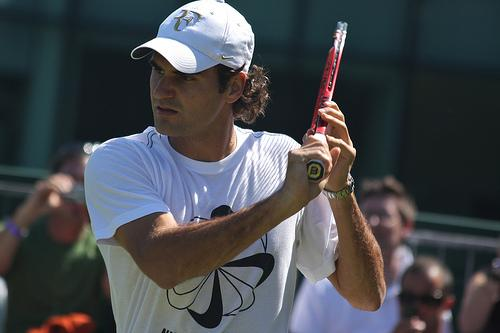What do people wear on their heads in the image? Several people wear hats in this image, including a white hat, a white cap, and a cap with a curled bill. Can you describe the details of the tennis player's outfit? The tennis player is wearing a short-sleeve white t-shirt with a black round design on the chest, a white hat with a letter f and brown curves on it, and a silver wristwatch on his left wrist. Please mention the colors of the tennis racquet and explain its position concerning the player. The tennis racquet is red, white, and blue and is held over the player's shoulder with both hands. What type of hairstyle does the tennis player have? The tennis player has dark brown curly hair, which sticks out from under the back of his cap. Count the number of visible accessories the tennis player is wearing. The tennis player is wearing three visible accessories: a white hat with a design, a silver watch on his left wrist, and a pair of dark sunglasses. What are the people in the background doing? Spectators in the background are watching the tennis player, while a woman takes a photo with her camera and another man records the race on his smartphone. What are the different objects related to a starter gun in the image, and describe their positions. There's a red shaft of starter gun near the top right side of the image and a very bottom of the starter gun and part of a handle towards the middle right of the image. In the scene, describe any interaction between the objects and the tennis player. The tennis player interacts with the racket by holding it with both hands over his shoulder, while his bent elbow crosses his chest and his cap casts a shadow on itself. Assess the overall sentiment or feeling conveyed by the image.  The image conveys a sense of excitement and focus, as the tennis player concentrates on the game, and the spectators watch intently or capture the moment with their devices. Look for the little boy on the far left of the image, wearing a green shirt and holding an ice cream cone. What flavor do you think it is? There is no mention of a little boy or any children in the image information. By posing a question and prompting the viewer to guess the ice cream flavor, it distracts from the actual objects and creates intrigue around a nonexistent figure. What is the main color of the man's hat? White Which of the following colors is an element of the tennis racquet's design? (a) Red, white, and blue (b) Orange and green (c) Purple and yellow (a) Red, white, and blue What is the woman in the back doing? Taking a photo What kind of racket is the tennis player holding? A red, white, and blue tennis racket Is the man wearing his silver watch on his right or left wrist? Left wrist Isn't it interesting how the yellow umbrella behind the spectators perfectly matches the man's tennis shorts? Observe how it adds a pop of color to the otherwise dull background. No, it's not mentioned in the image. Explain what the man is doing with the tennis racket. Holding it over one shoulder with both hands What is the man wearing a white hat doing? Recording a race on his phone What emotion is being displayed by the man with the serious expression and focused eyes? Determination Does the tennis player have short or long hair? Short curly hair Describe the man's hairstyle. Dark brown curly hair Describe the design on the man's white cap. A brown letter "f" on the cap What does the tennis player have on his wrist? A silver watch What kind of shirt is the man wearing? A white tee shirt with a black round design on the chest Name three physical features of the man wearing the white cap. Curly hair, silver watch, and sunglasses Identify the activity being performed in the image. Man playing tennis List the three main colors of the tennis raquet. Red, white, and blue What is the main feature of the man's t-shirt design? A black round graphic on the chest area Identify the type of headwear the tennis player is wearing. A white cap with a curled bill What accessory does the man wear on his face? Dark sunglasses 